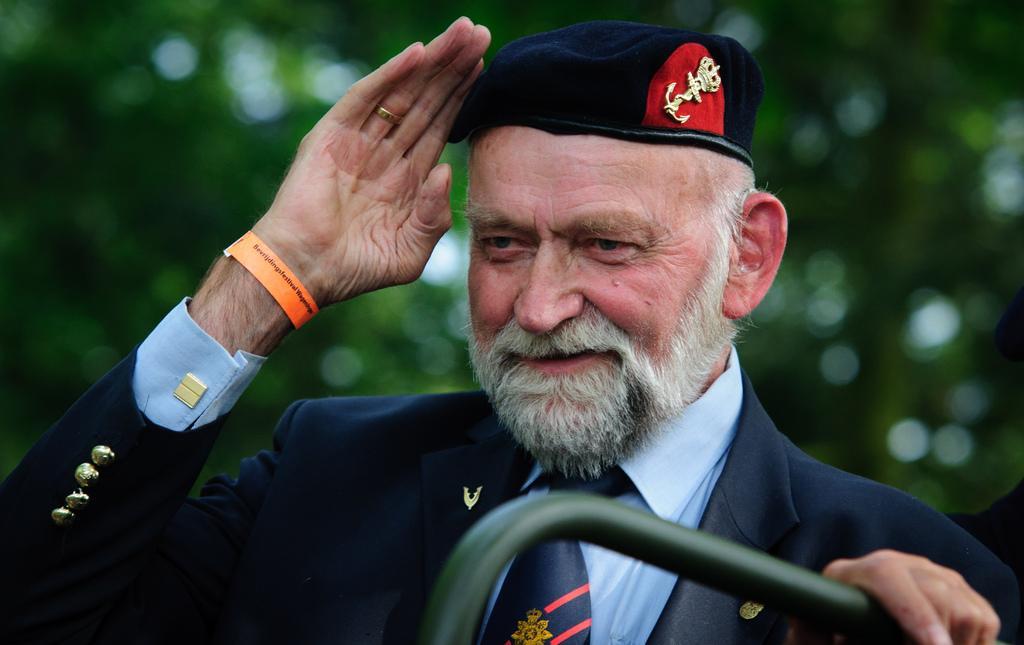Can you describe this image briefly? In this image we can see a person wearing cap. At the bottom we can see a handle. In the background it is green and blur. 